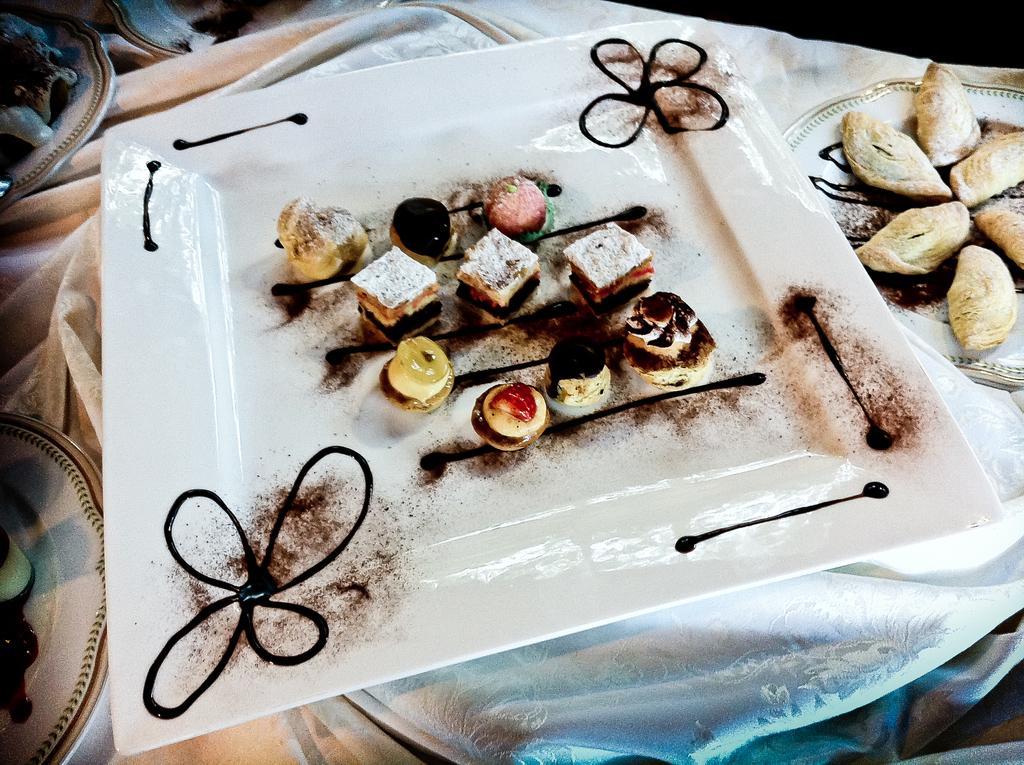In one or two sentences, can you explain what this image depicts? In this image we can see there is a plate and food item in it, on the right there is a food item in the plate and some objects on the table. 